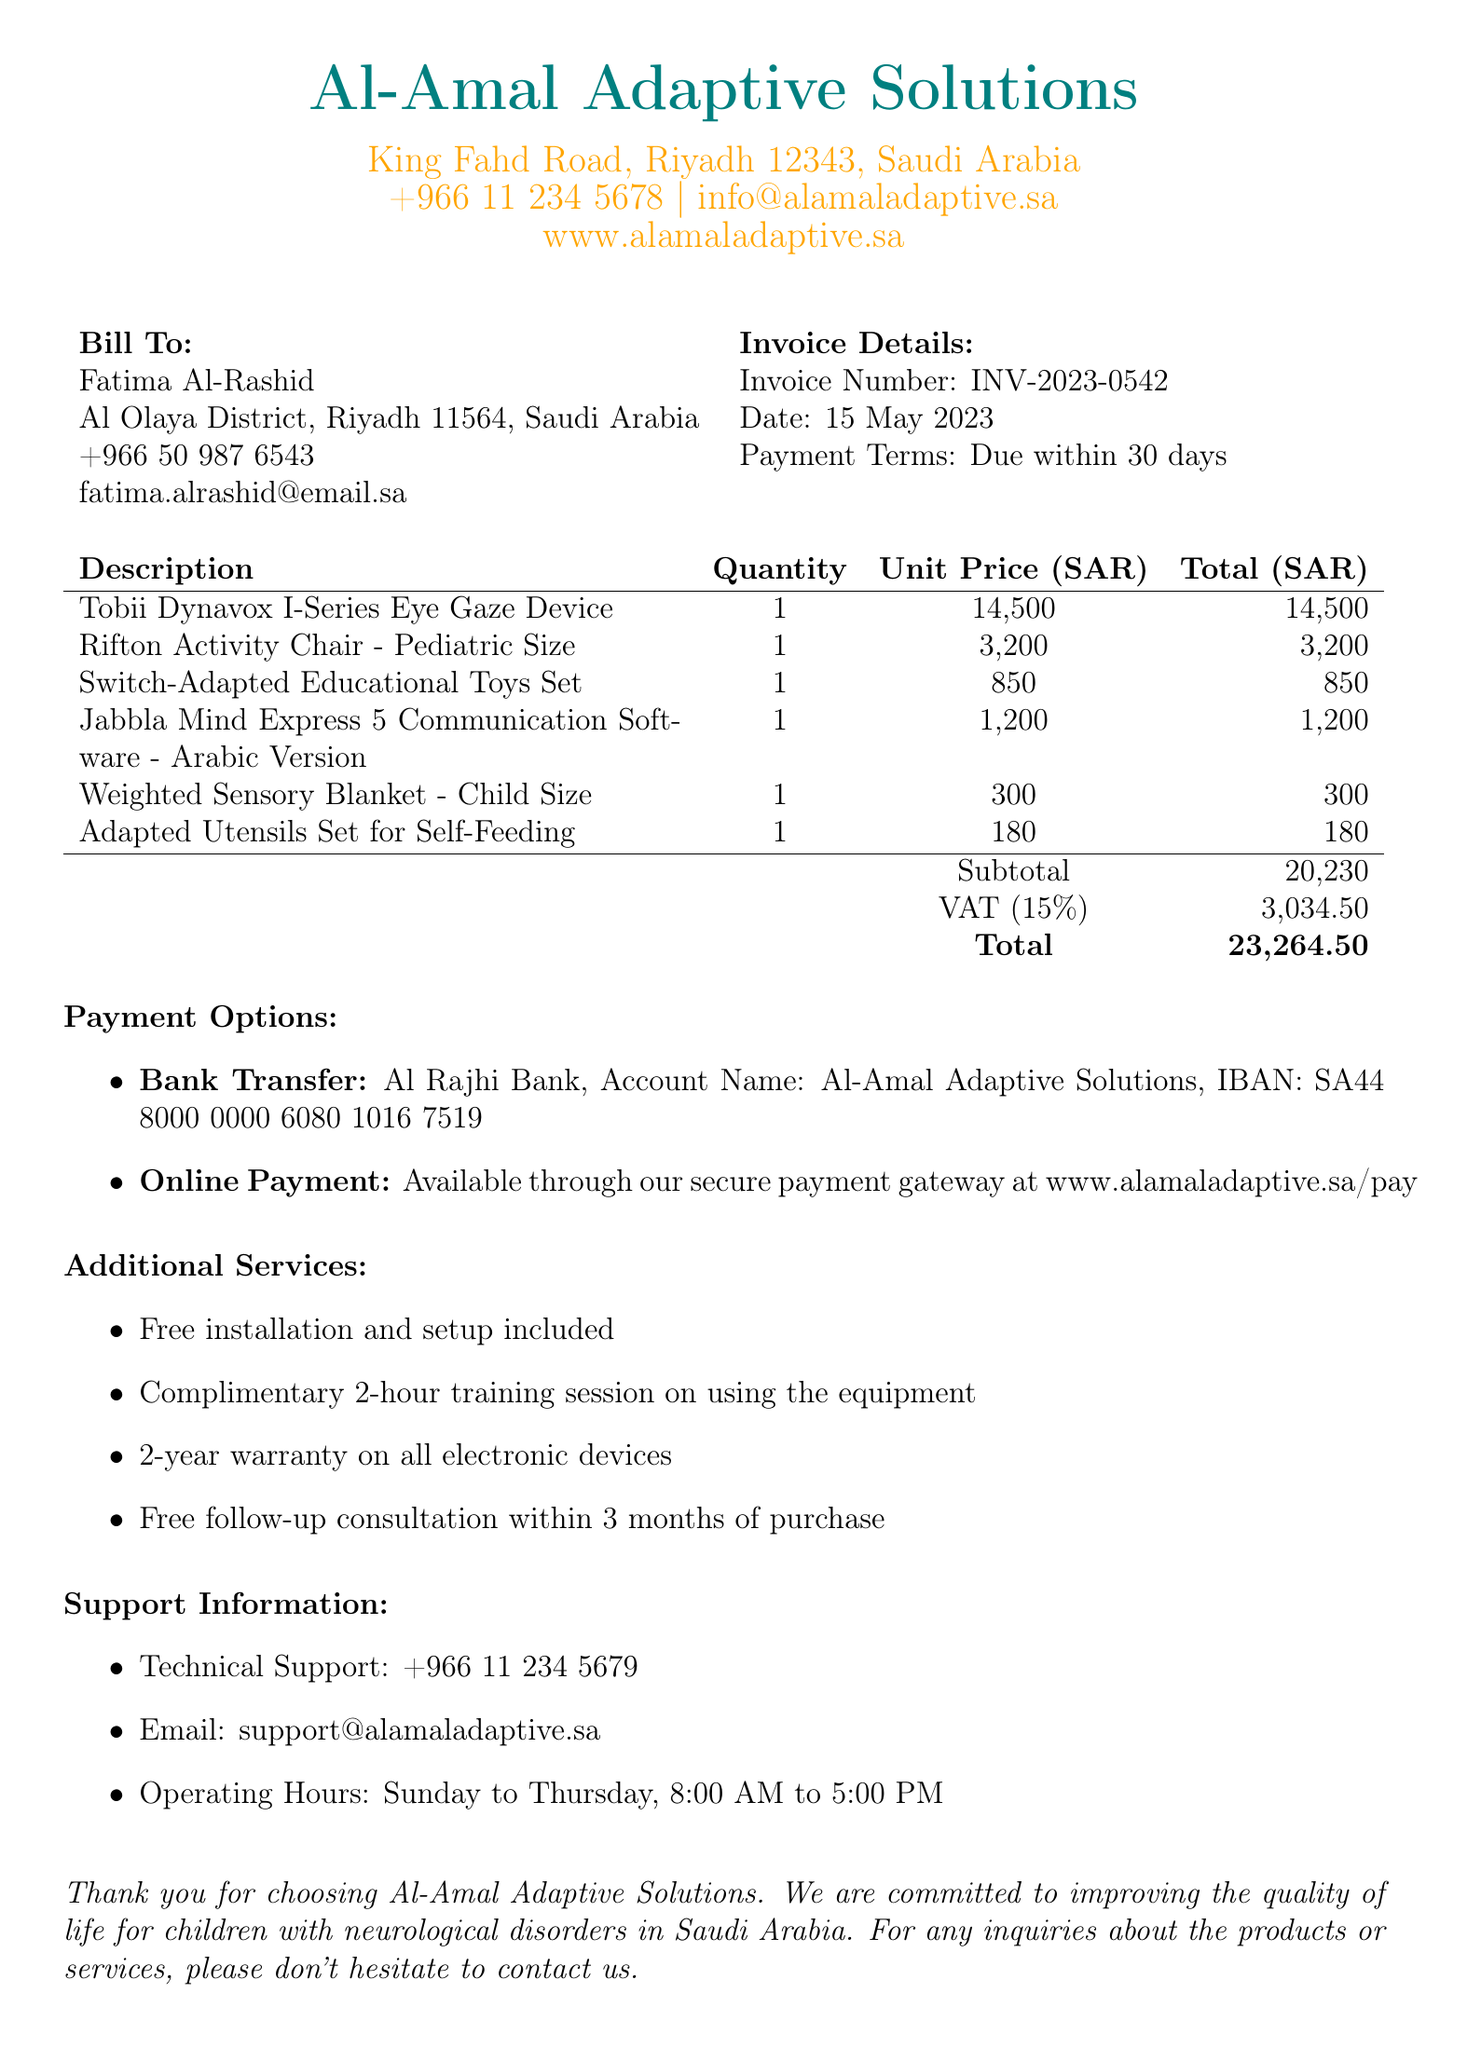What is the company name? The company name is listed at the top of the document, which is the organization providing the services.
Answer: Al-Amal Adaptive Solutions What is the invoice number? The invoice number is specified in the invoice details section, which uniquely identifies this particular invoice.
Answer: INV-2023-0542 What is the total amount due? The total amount due is the final figure listed in the additional info section, summing up the subtotal and VAT.
Answer: 23,264.50 How many items were purchased? The number of items can be determined by counting the entries in the items section of the invoice.
Answer: 6 What is the date of the invoice? The date of the invoice is specified in the invoice details section and indicates when the invoice was issued.
Answer: 15 May 2023 What type of training is offered for free? The document mentions complimentary training services that are provided to assist the client in using the equipment effectively.
Answer: 2-hour training session What is the warranty period for the products? The warranty period is clearly stated in the additional services section, indicating the durability of the electronic items.
Answer: 2-year warranty What is the VAT amount? The VAT amount provided in the additional info section is crucial for understanding the tax applied to the purchase.
Answer: 3,034.50 How can payments be made? The document outlines options available for making payments, specifying two different payment methods.
Answer: Bank transfer and online payment 